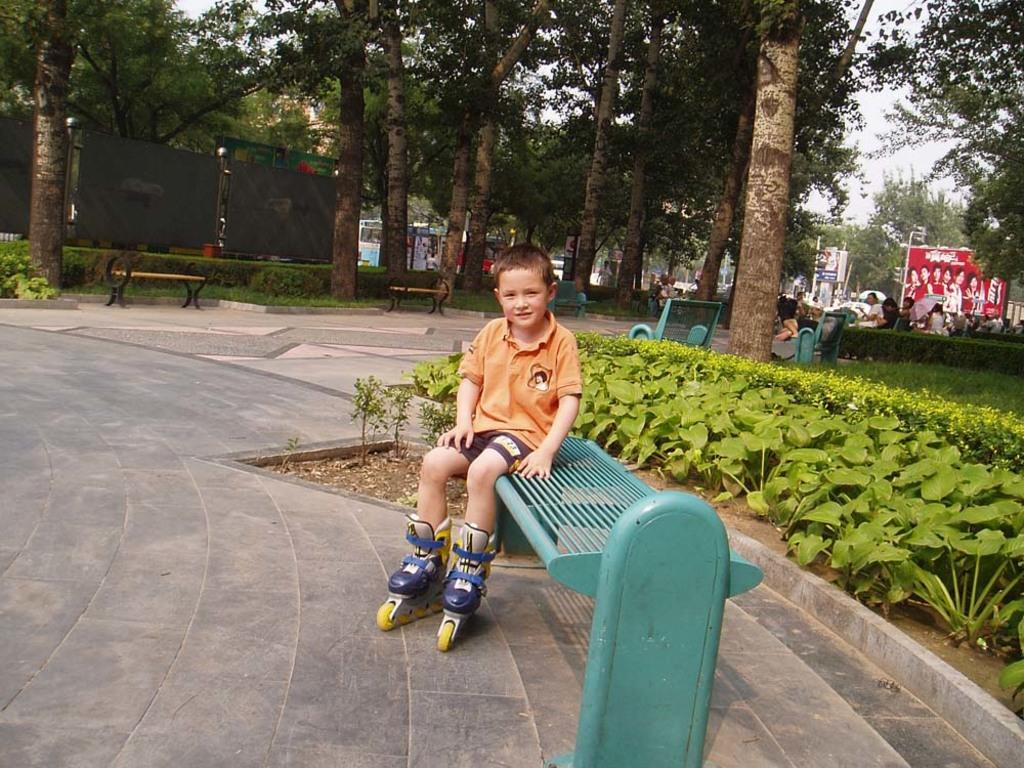What type of natural elements can be seen in the image? There are trees and plants in the image. What type of seating is available in the image? There are benches in the image. What are the people in the image doing? There are people seated in the image. What type of advertisement is present in the image? There is a hoarding in the image. Can you describe the boy in the image? The boy is seated on a bench and is wearing skates on his legs. What is the weather like in the image? The sky is cloudy in the image. How many girls are playing with the frog in the image? There are no girls or frogs present in the image. 